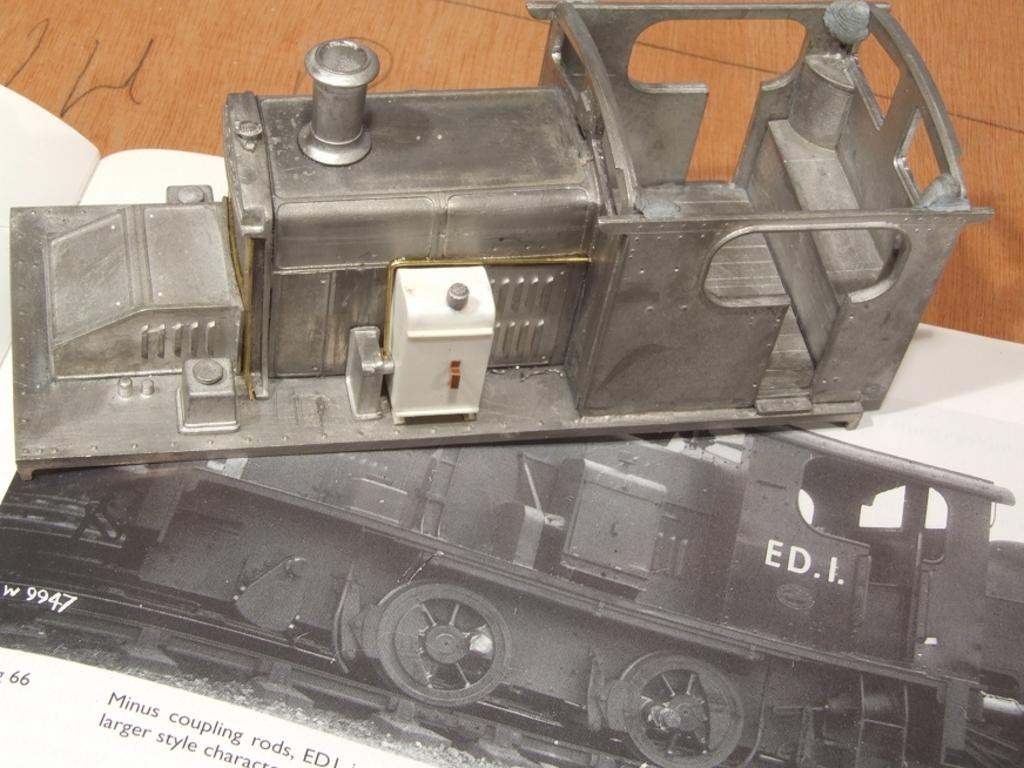What is the main subject of the image on the page of the book? The main subject of the image on the page of the book is a toy engine. What else can be found on the page of the book? The page contains an image and text. What is the image depicting? The image depicts a train on a railway track. Where is the book located in the image? The book is on a wooden table. What time of day is it in the image, and what channel is the train on? The time of day and the channel are not mentioned or depicted in the image. The image only shows a toy engine on a page of a book, with an image of a train on a railway track. 